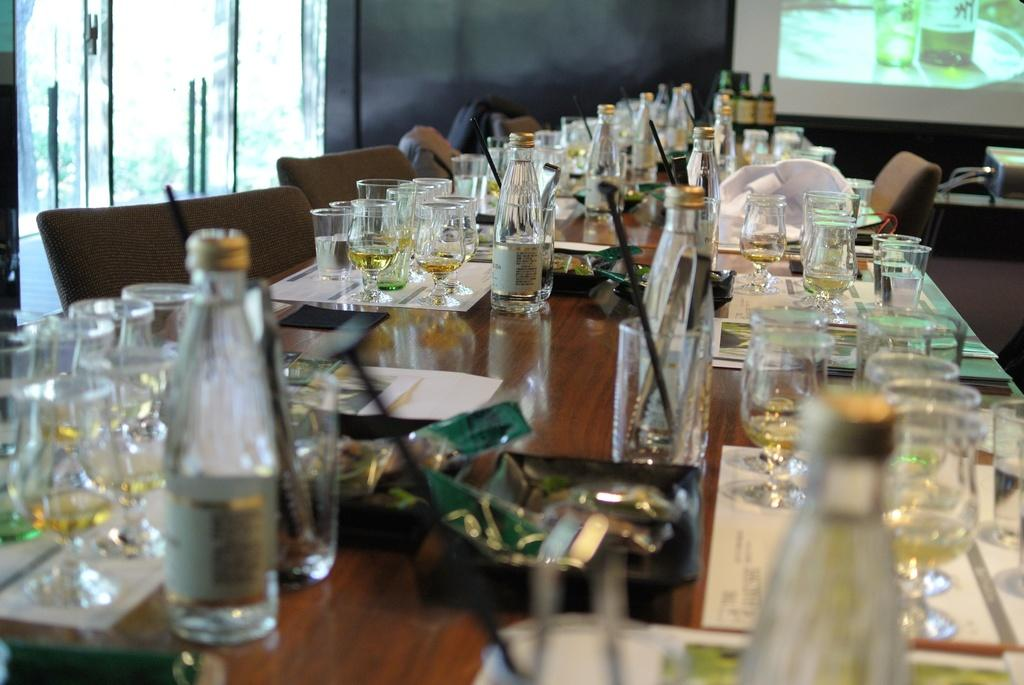What type of furniture is present in the image? There is a table and chairs in the image. What type of doors can be seen in the image? There are glass doors in the image. What is placed on the table in the image? There is a group of glasses and bottles on the table. What is inside the bottles on the table? The bottles contain wine. What type of square frame is hanging on the wall in the image? There is no square frame present in the image. How does the drain in the image affect the table setting? There is no drain present in the image. 